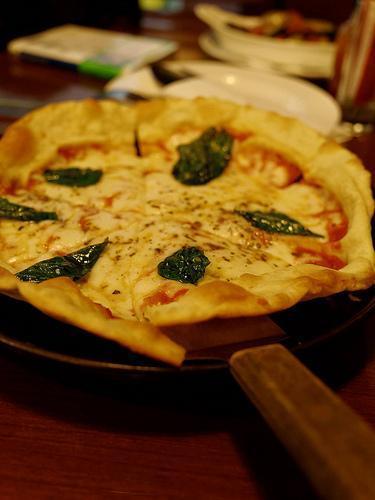How many slices are there?
Give a very brief answer. 6. 